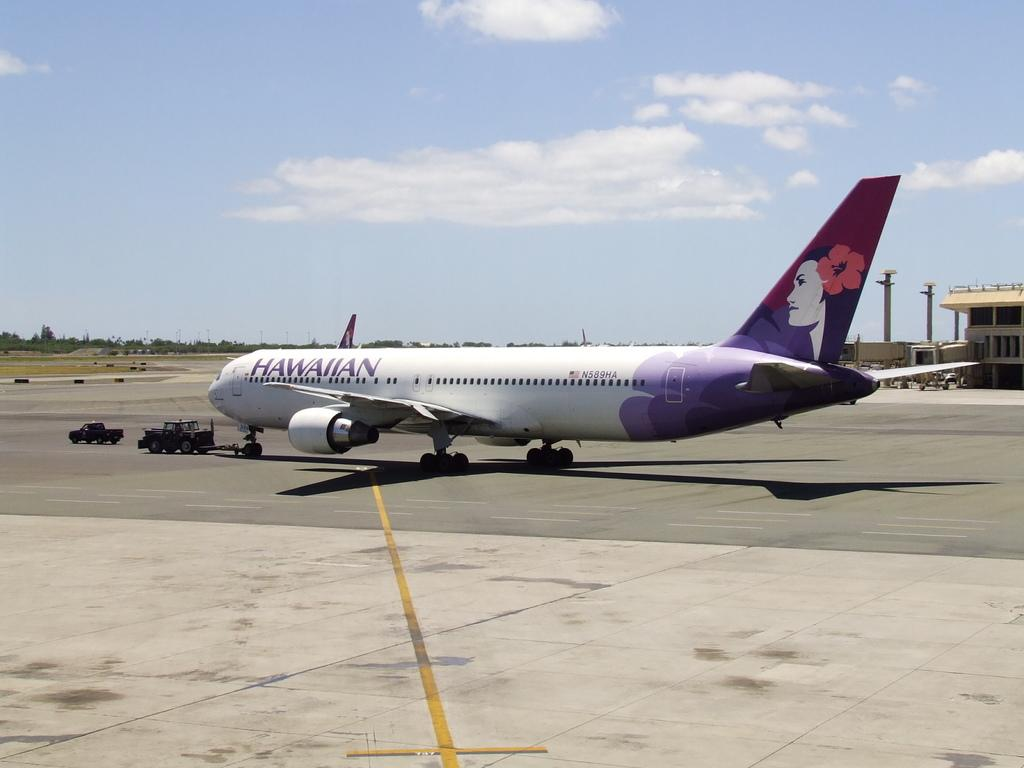<image>
Relay a brief, clear account of the picture shown. the word Hawaiian is on the plane that is purple 